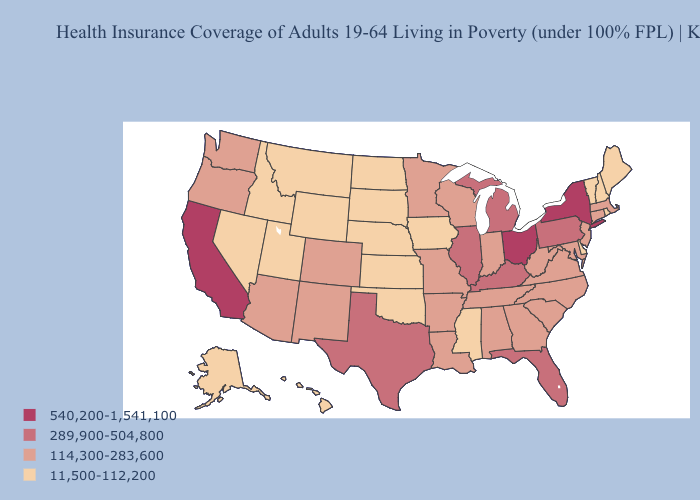How many symbols are there in the legend?
Write a very short answer. 4. Does Oregon have a higher value than Washington?
Keep it brief. No. Does Mississippi have the same value as Iowa?
Answer briefly. Yes. Which states hav the highest value in the South?
Keep it brief. Florida, Kentucky, Texas. Name the states that have a value in the range 289,900-504,800?
Short answer required. Florida, Illinois, Kentucky, Michigan, Pennsylvania, Texas. Which states hav the highest value in the Northeast?
Concise answer only. New York. What is the lowest value in states that border Washington?
Keep it brief. 11,500-112,200. What is the value of Colorado?
Write a very short answer. 114,300-283,600. Among the states that border Wyoming , does Colorado have the lowest value?
Give a very brief answer. No. Among the states that border Wisconsin , which have the highest value?
Write a very short answer. Illinois, Michigan. Name the states that have a value in the range 289,900-504,800?
Give a very brief answer. Florida, Illinois, Kentucky, Michigan, Pennsylvania, Texas. Does Michigan have a lower value than New York?
Be succinct. Yes. How many symbols are there in the legend?
Keep it brief. 4. 